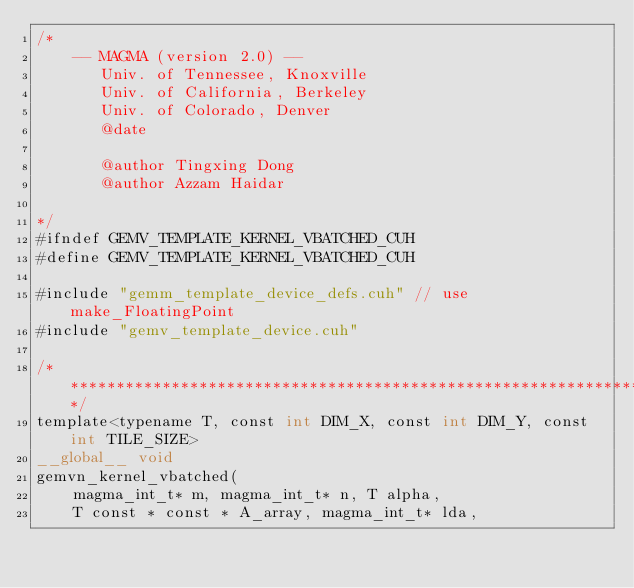Convert code to text. <code><loc_0><loc_0><loc_500><loc_500><_Cuda_>/*
    -- MAGMA (version 2.0) --
       Univ. of Tennessee, Knoxville
       Univ. of California, Berkeley
       Univ. of Colorado, Denver
       @date

       @author Tingxing Dong
       @author Azzam Haidar

*/
#ifndef GEMV_TEMPLATE_KERNEL_VBATCHED_CUH
#define GEMV_TEMPLATE_KERNEL_VBATCHED_CUH

#include "gemm_template_device_defs.cuh" // use make_FloatingPoint
#include "gemv_template_device.cuh"

/******************************************************************************/
template<typename T, const int DIM_X, const int DIM_Y, const int TILE_SIZE>
__global__ void
gemvn_kernel_vbatched(
    magma_int_t* m, magma_int_t* n, T alpha,
    T const * const * A_array, magma_int_t* lda,</code> 